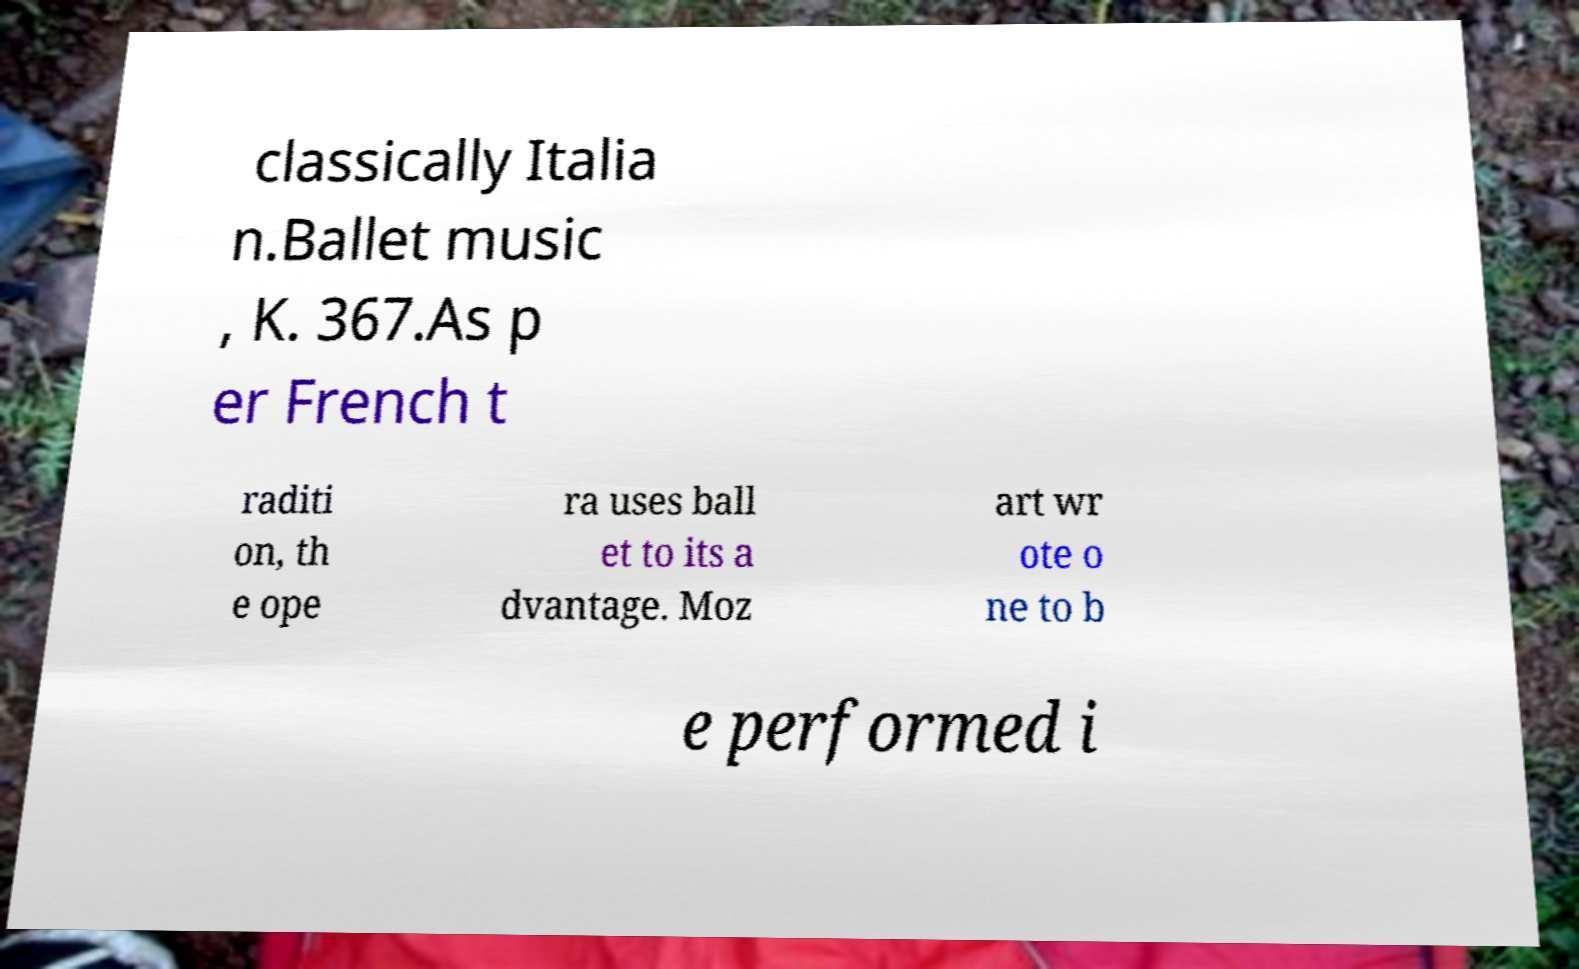For documentation purposes, I need the text within this image transcribed. Could you provide that? classically Italia n.Ballet music , K. 367.As p er French t raditi on, th e ope ra uses ball et to its a dvantage. Moz art wr ote o ne to b e performed i 